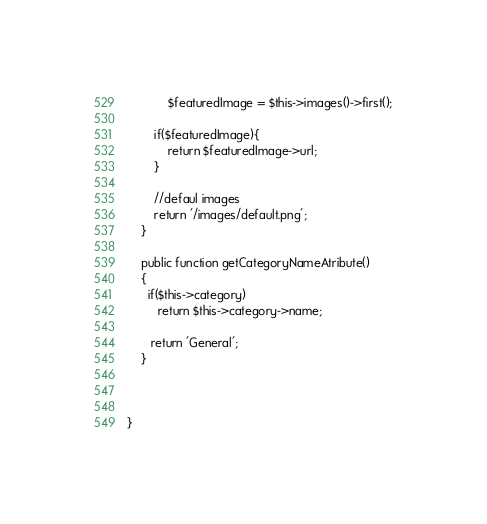<code> <loc_0><loc_0><loc_500><loc_500><_PHP_>        	$featuredImage = $this->images()->first();

        if($featuredImage){
        	return $featuredImage->url;
        }

        //defaul images
        return '/images/default.png';
    }

    public function getCategoryNameAtribute()
    {
      if($this->category)
         return $this->category->name;

       return 'General'; 
    }



}
</code> 